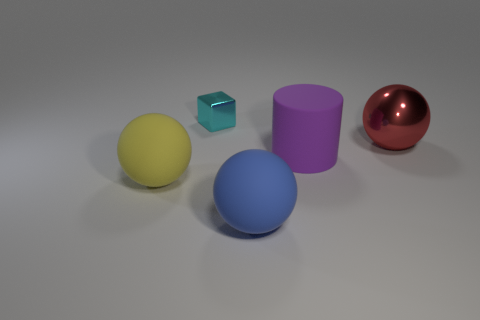Are there more large red metallic balls that are behind the red sphere than rubber cylinders that are right of the matte cylinder?
Your answer should be very brief. No. There is a metal thing on the right side of the big blue object; how many purple objects are on the right side of it?
Your answer should be very brief. 0. There is a large rubber object behind the yellow matte object; is it the same shape as the big yellow rubber thing?
Provide a short and direct response. No. There is a blue thing that is the same shape as the yellow thing; what is it made of?
Your answer should be compact. Rubber. What number of balls are the same size as the shiny cube?
Your response must be concise. 0. What is the color of the ball that is right of the small shiny thing and on the left side of the large red thing?
Provide a succinct answer. Blue. Are there fewer small shiny objects than rubber spheres?
Make the answer very short. Yes. There is a large cylinder; does it have the same color as the large matte object that is in front of the big yellow sphere?
Offer a terse response. No. Are there the same number of big metal spheres that are to the left of the big rubber cylinder and large yellow matte things right of the cyan thing?
Provide a succinct answer. Yes. What number of other blue rubber things have the same shape as the small object?
Give a very brief answer. 0. 